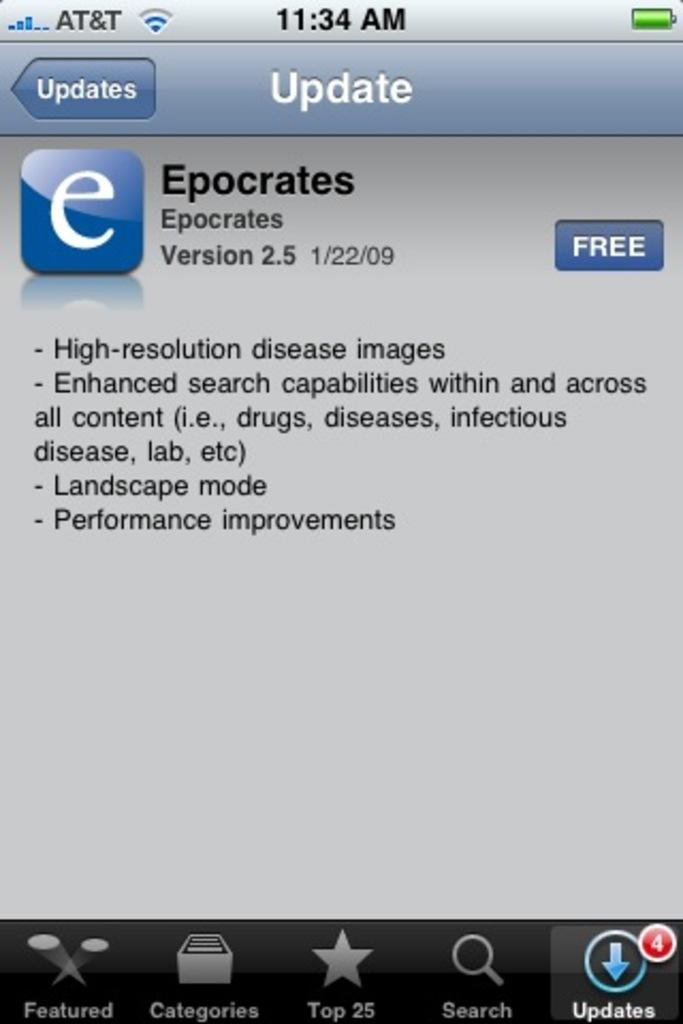<image>
Write a terse but informative summary of the picture. an AT&T phones is open to Epocrates app 